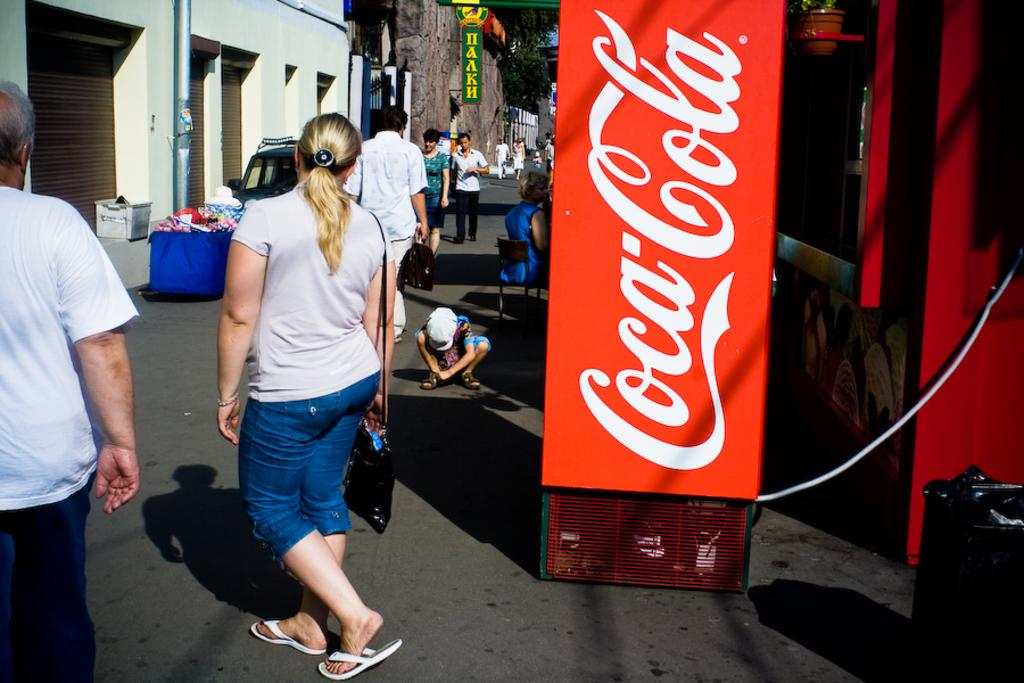What are the people in the image doing? The people in the image are walking down the street. What can be seen on either side of the street? There are buildings on either side of the street. Can you tell me how many sticks the grandfather is holding in the image? There is no grandfather or sticks present in the image. 